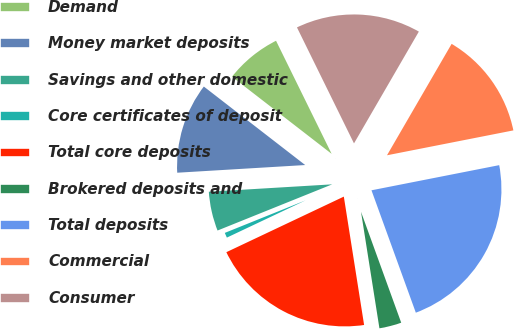Convert chart. <chart><loc_0><loc_0><loc_500><loc_500><pie_chart><fcel>Demand<fcel>Money market deposits<fcel>Savings and other domestic<fcel>Core certificates of deposit<fcel>Total core deposits<fcel>Brokered deposits and<fcel>Total deposits<fcel>Commercial<fcel>Consumer<nl><fcel>7.24%<fcel>11.44%<fcel>5.14%<fcel>0.94%<fcel>20.46%<fcel>3.04%<fcel>22.56%<fcel>13.54%<fcel>15.64%<nl></chart> 